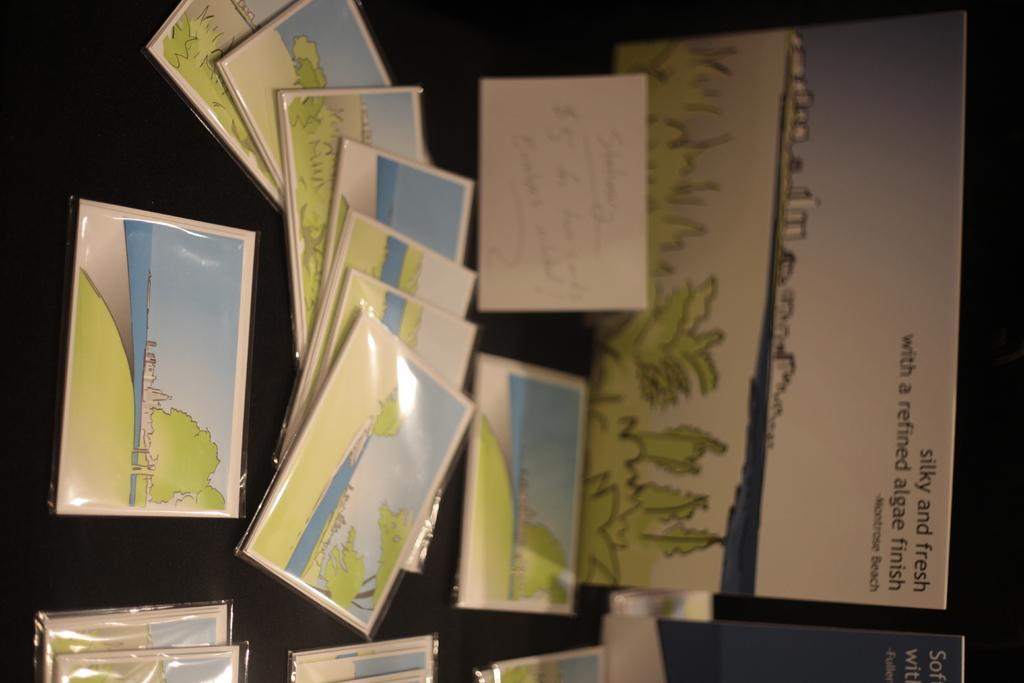<image>
Create a compact narrative representing the image presented. Montrose Beach is know as being silly and fresh with a refined algae finish. 